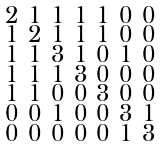<formula> <loc_0><loc_0><loc_500><loc_500>\begin{smallmatrix} 2 & 1 & 1 & 1 & 1 & 0 & 0 \\ 1 & 2 & 1 & 1 & 1 & 0 & 0 \\ 1 & 1 & 3 & 1 & 0 & 1 & 0 \\ 1 & 1 & 1 & 3 & 0 & 0 & 0 \\ 1 & 1 & 0 & 0 & 3 & 0 & 0 \\ 0 & 0 & 1 & 0 & 0 & 3 & 1 \\ 0 & 0 & 0 & 0 & 0 & 1 & 3 \end{smallmatrix}</formula> 